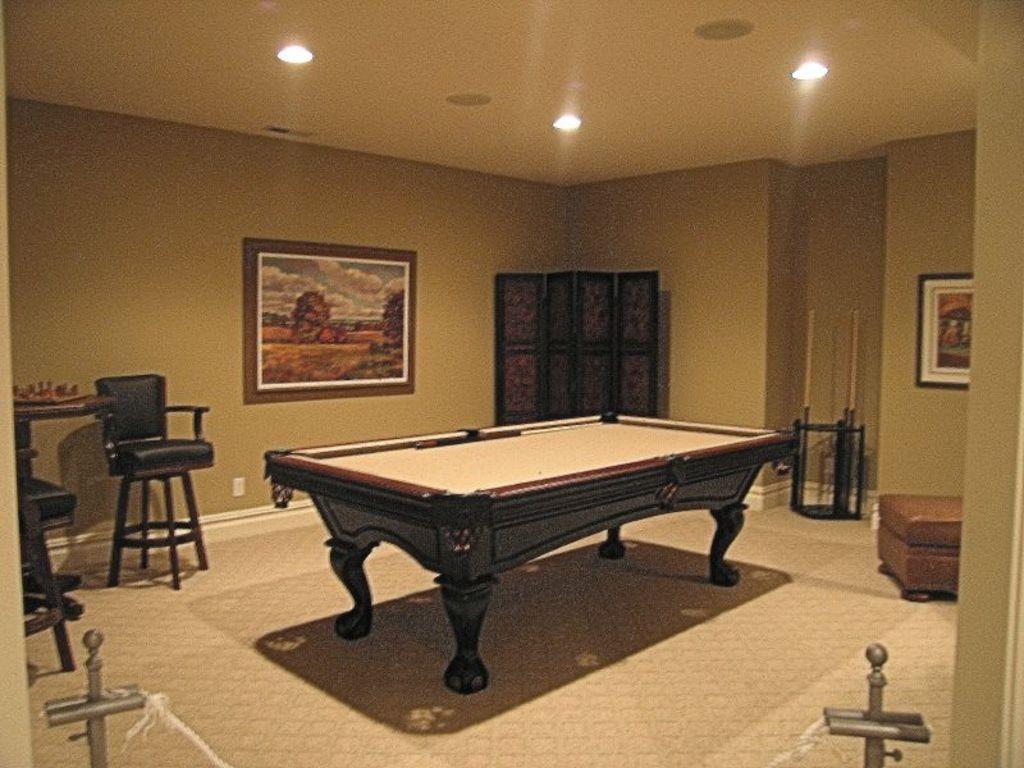In one or two sentences, can you explain what this image depicts? The picture is clicked inside a room where there is a wooden snooker table and in the background we observe a chair , painting , designed wall and there is a brown color sofa to the right side of the image. There are even lights attached to the roof. 